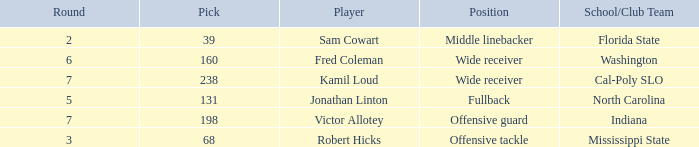Which Round has a School/Club Team of north carolina, and a Pick larger than 131? 0.0. 